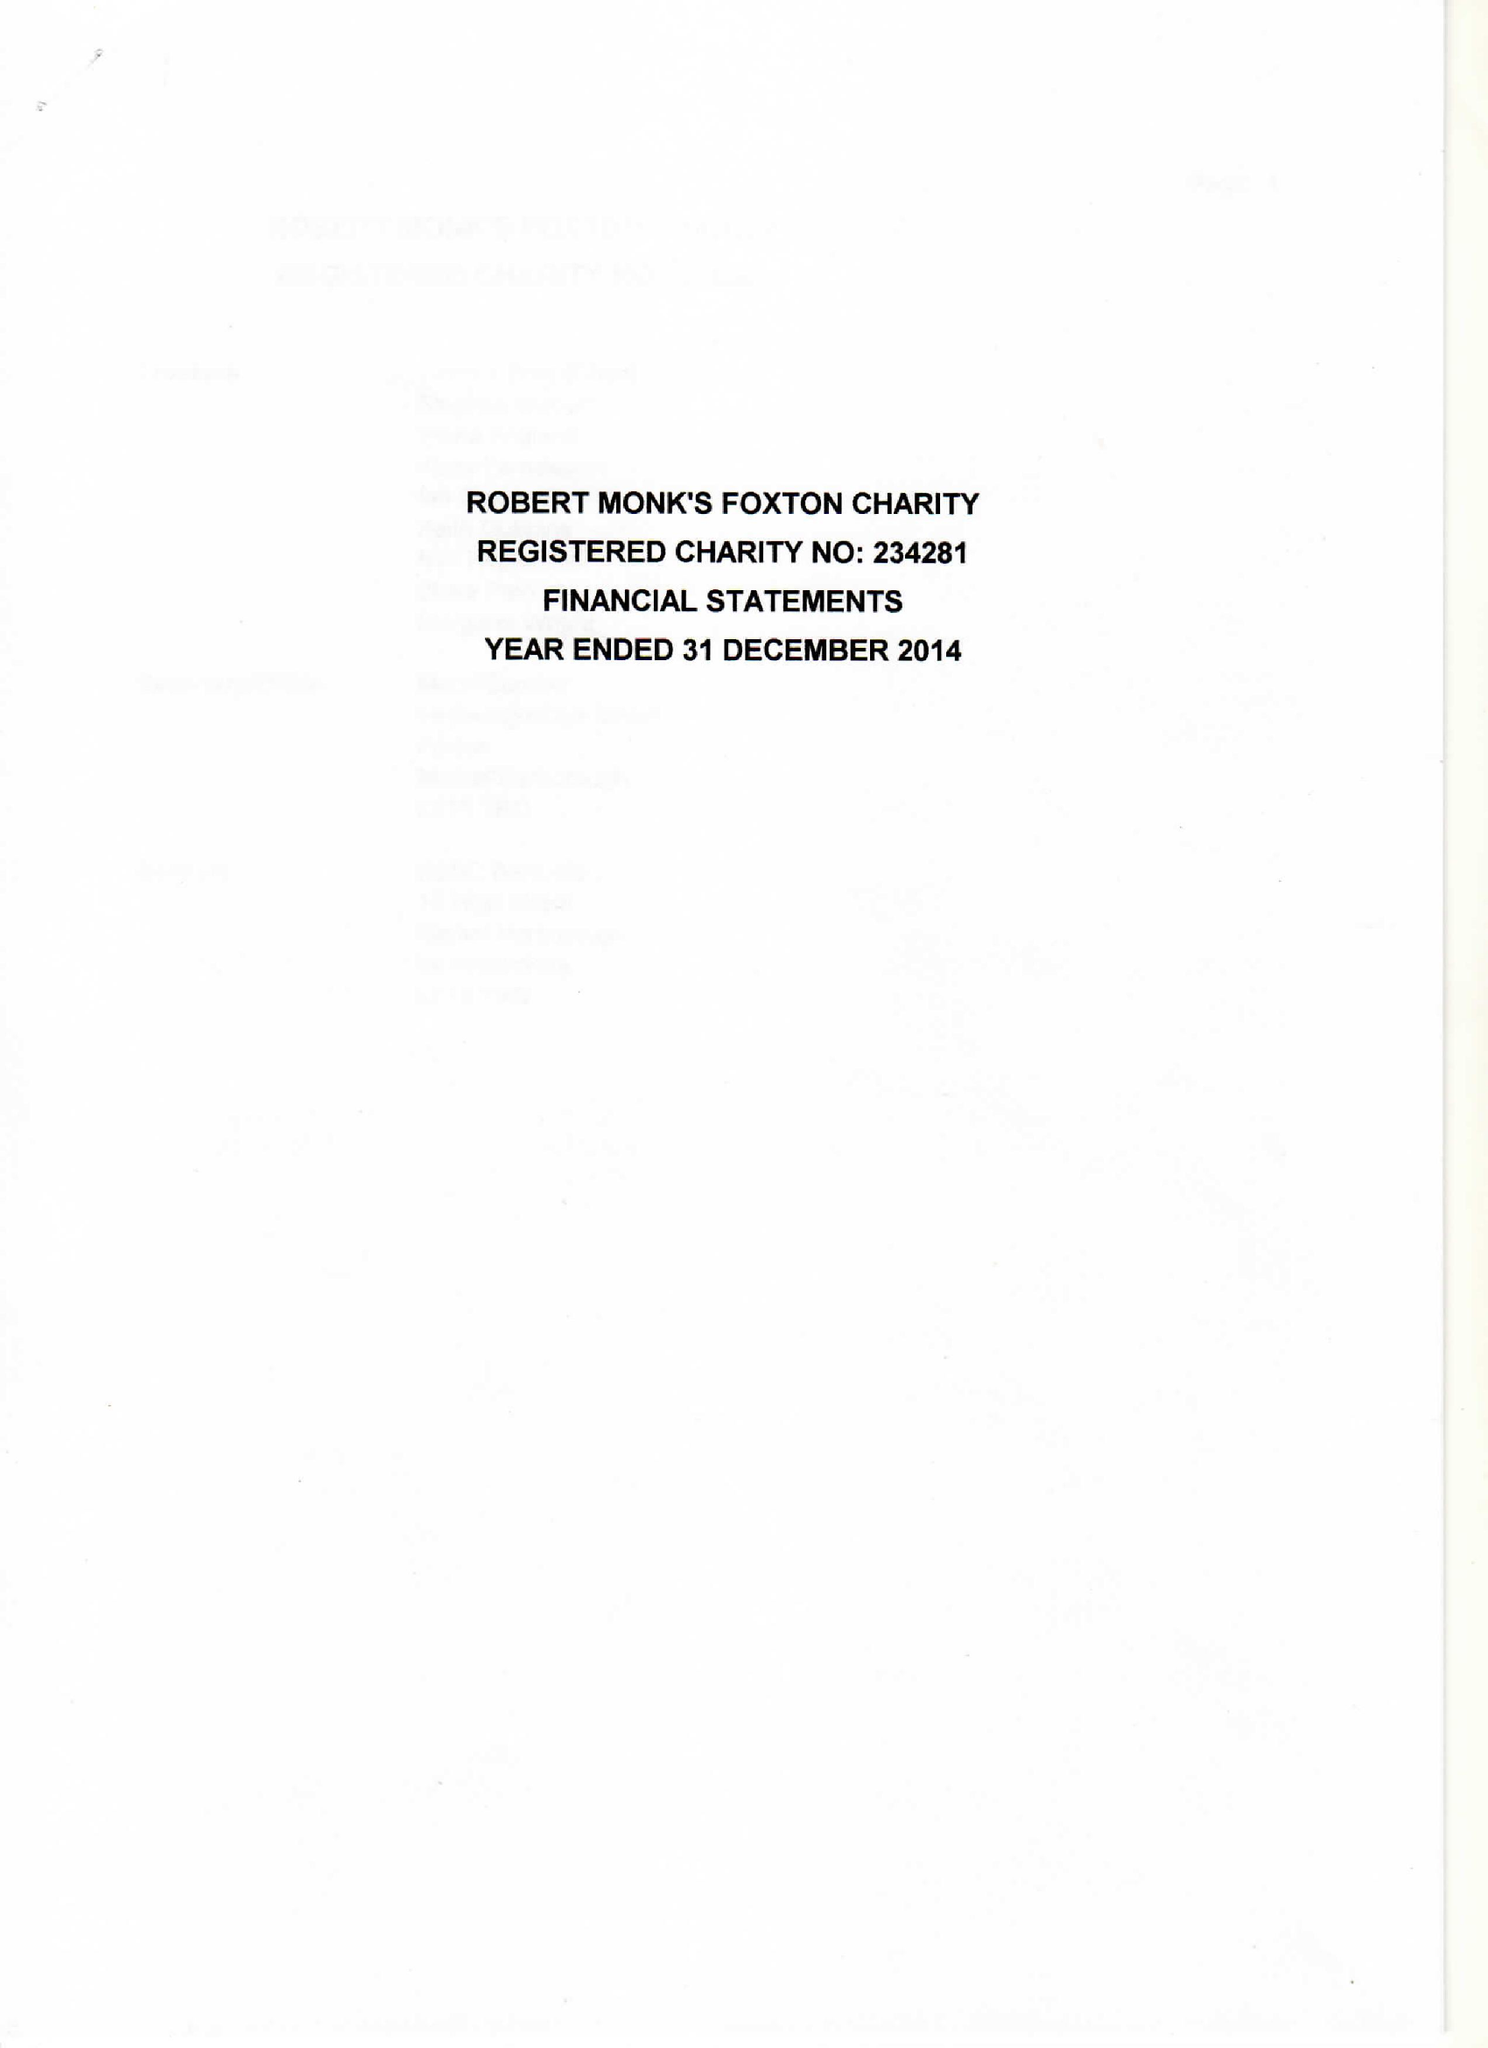What is the value for the income_annually_in_british_pounds?
Answer the question using a single word or phrase. 28364.00 